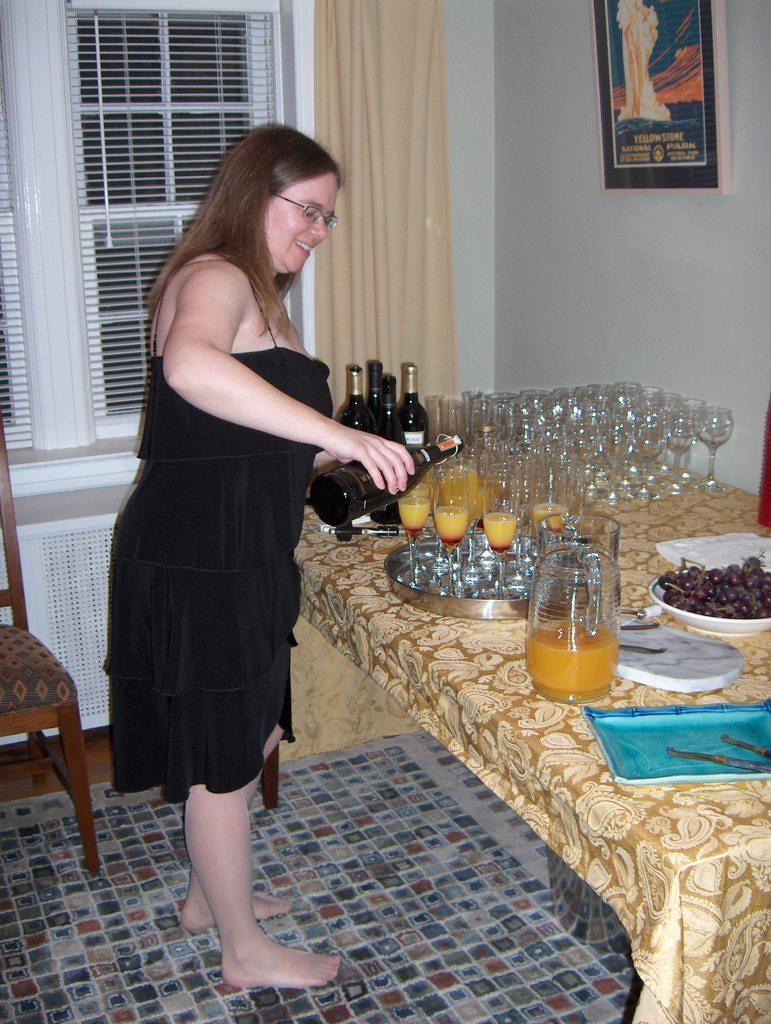Could you give a brief overview of what you see in this image? The women wearing black dress is standing and holding a drink bottle in her hand and there are many glasses and some bottles on the table. 